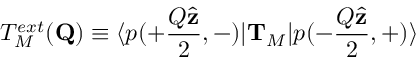Convert formula to latex. <formula><loc_0><loc_0><loc_500><loc_500>T _ { M } ^ { e x t } ( { Q } ) \equiv \langle p ( + \frac { Q \hat { z } } { 2 } , - ) | { T } _ { M } | p ( - \frac { Q \hat { z } } { 2 } , + ) \rangle</formula> 